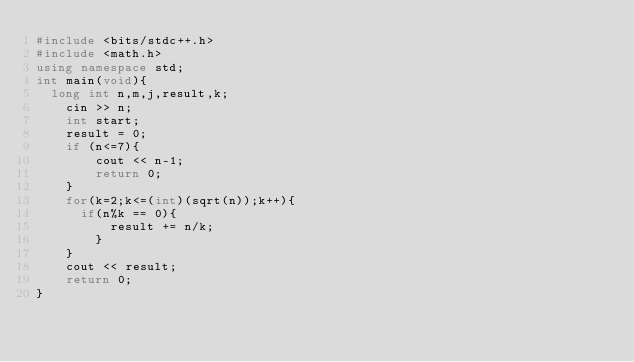Convert code to text. <code><loc_0><loc_0><loc_500><loc_500><_C++_>#include <bits/stdc++.h>
#include <math.h>
using namespace std;
int main(void){
	long int n,m,j,result,k;
  	cin >> n;
  	int start;
    result = 0;
  	if (n<=7){
        cout << n-1;
        return 0;
    }
  	for(k=2;k<=(int)(sqrt(n));k++){
    	if(n%k == 0){
        	result += n/k;
        }
    }
  	cout << result;
  	return 0;
}</code> 